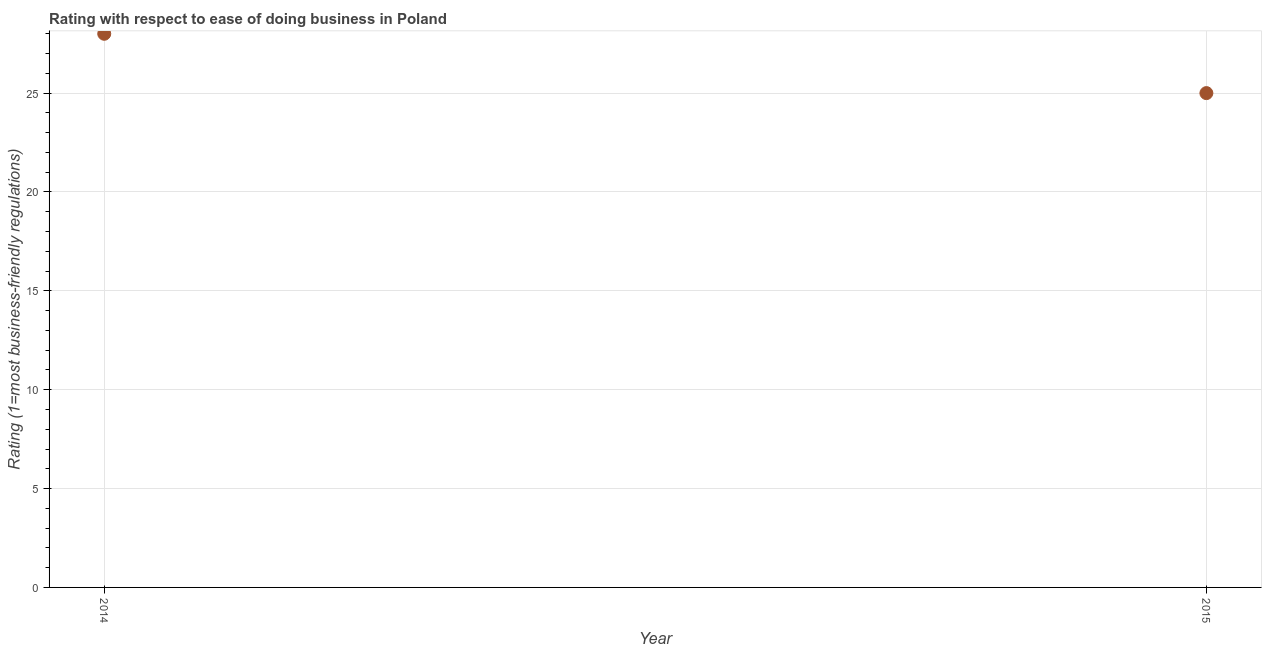What is the ease of doing business index in 2014?
Make the answer very short. 28. Across all years, what is the maximum ease of doing business index?
Give a very brief answer. 28. Across all years, what is the minimum ease of doing business index?
Keep it short and to the point. 25. In which year was the ease of doing business index minimum?
Provide a short and direct response. 2015. What is the sum of the ease of doing business index?
Offer a terse response. 53. What is the difference between the ease of doing business index in 2014 and 2015?
Your answer should be very brief. 3. What is the average ease of doing business index per year?
Offer a very short reply. 26.5. What is the median ease of doing business index?
Ensure brevity in your answer.  26.5. Do a majority of the years between 2015 and 2014 (inclusive) have ease of doing business index greater than 19 ?
Your answer should be very brief. No. What is the ratio of the ease of doing business index in 2014 to that in 2015?
Your answer should be very brief. 1.12. How many dotlines are there?
Offer a very short reply. 1. How many years are there in the graph?
Provide a succinct answer. 2. Are the values on the major ticks of Y-axis written in scientific E-notation?
Your answer should be compact. No. What is the title of the graph?
Give a very brief answer. Rating with respect to ease of doing business in Poland. What is the label or title of the X-axis?
Your response must be concise. Year. What is the label or title of the Y-axis?
Your answer should be very brief. Rating (1=most business-friendly regulations). What is the ratio of the Rating (1=most business-friendly regulations) in 2014 to that in 2015?
Give a very brief answer. 1.12. 